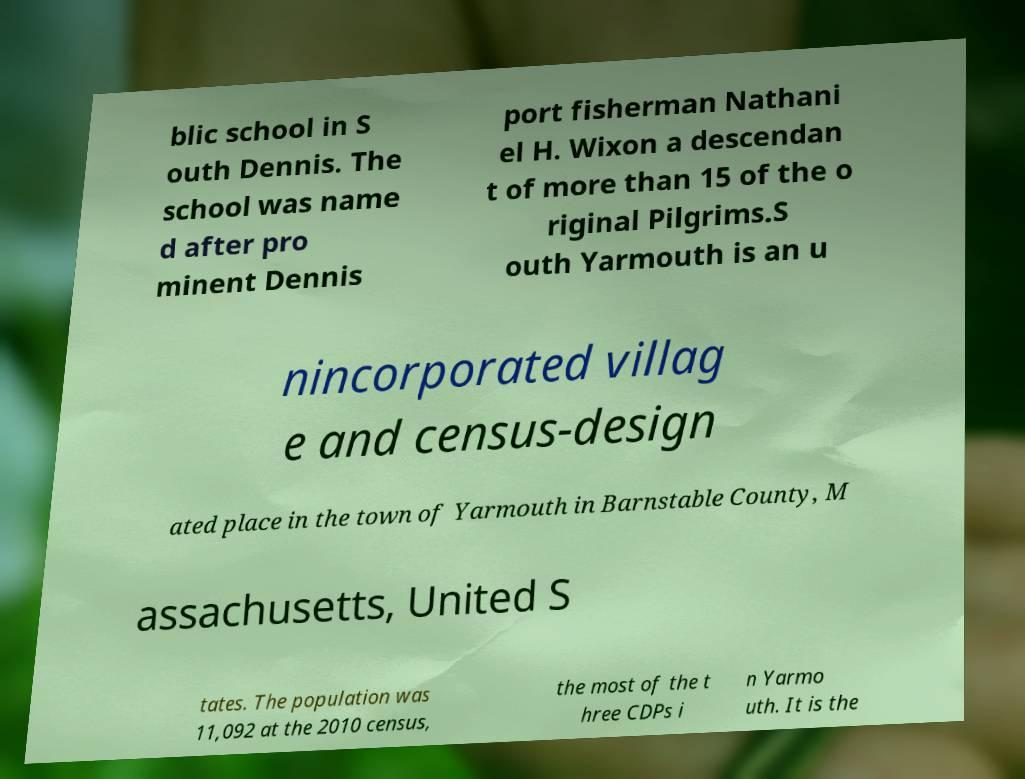Can you accurately transcribe the text from the provided image for me? blic school in S outh Dennis. The school was name d after pro minent Dennis port fisherman Nathani el H. Wixon a descendan t of more than 15 of the o riginal Pilgrims.S outh Yarmouth is an u nincorporated villag e and census-design ated place in the town of Yarmouth in Barnstable County, M assachusetts, United S tates. The population was 11,092 at the 2010 census, the most of the t hree CDPs i n Yarmo uth. It is the 